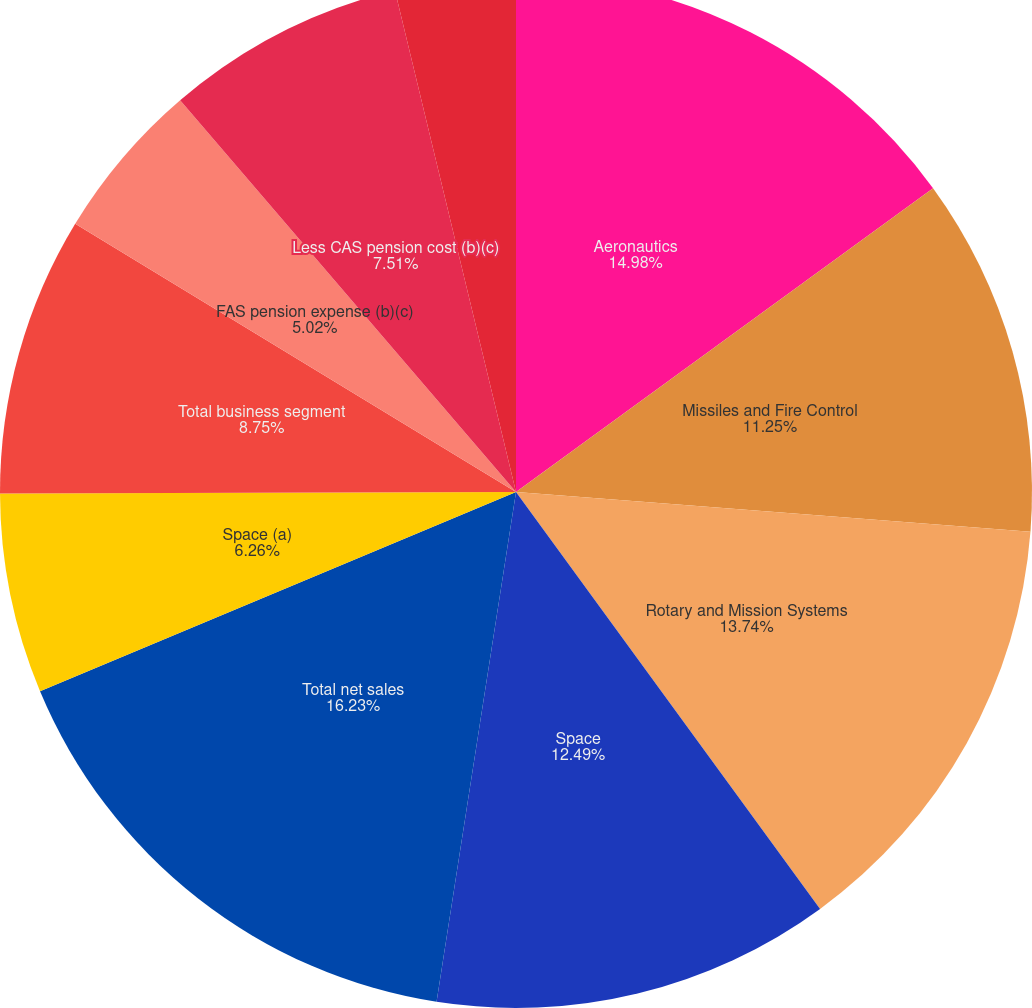<chart> <loc_0><loc_0><loc_500><loc_500><pie_chart><fcel>Aeronautics<fcel>Missiles and Fire Control<fcel>Rotary and Mission Systems<fcel>Space<fcel>Total net sales<fcel>Space (a)<fcel>Total business segment<fcel>FAS pension expense (b)(c)<fcel>Less CAS pension cost (b)(c)<fcel>FAS/CAS pension adjustment (d)<nl><fcel>14.98%<fcel>11.25%<fcel>13.74%<fcel>12.49%<fcel>16.23%<fcel>6.26%<fcel>8.75%<fcel>5.02%<fcel>7.51%<fcel>3.77%<nl></chart> 